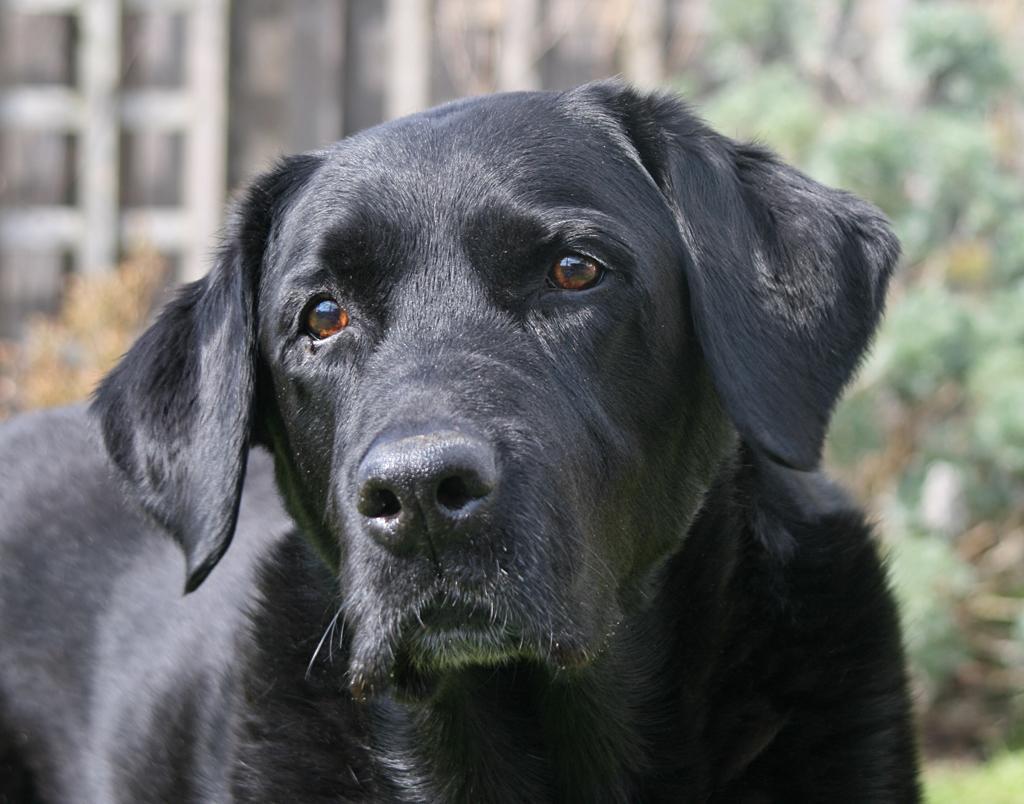Describe this image in one or two sentences. There is a black color dog as we can see in the middle of this image. There are trees and a building in the background. 